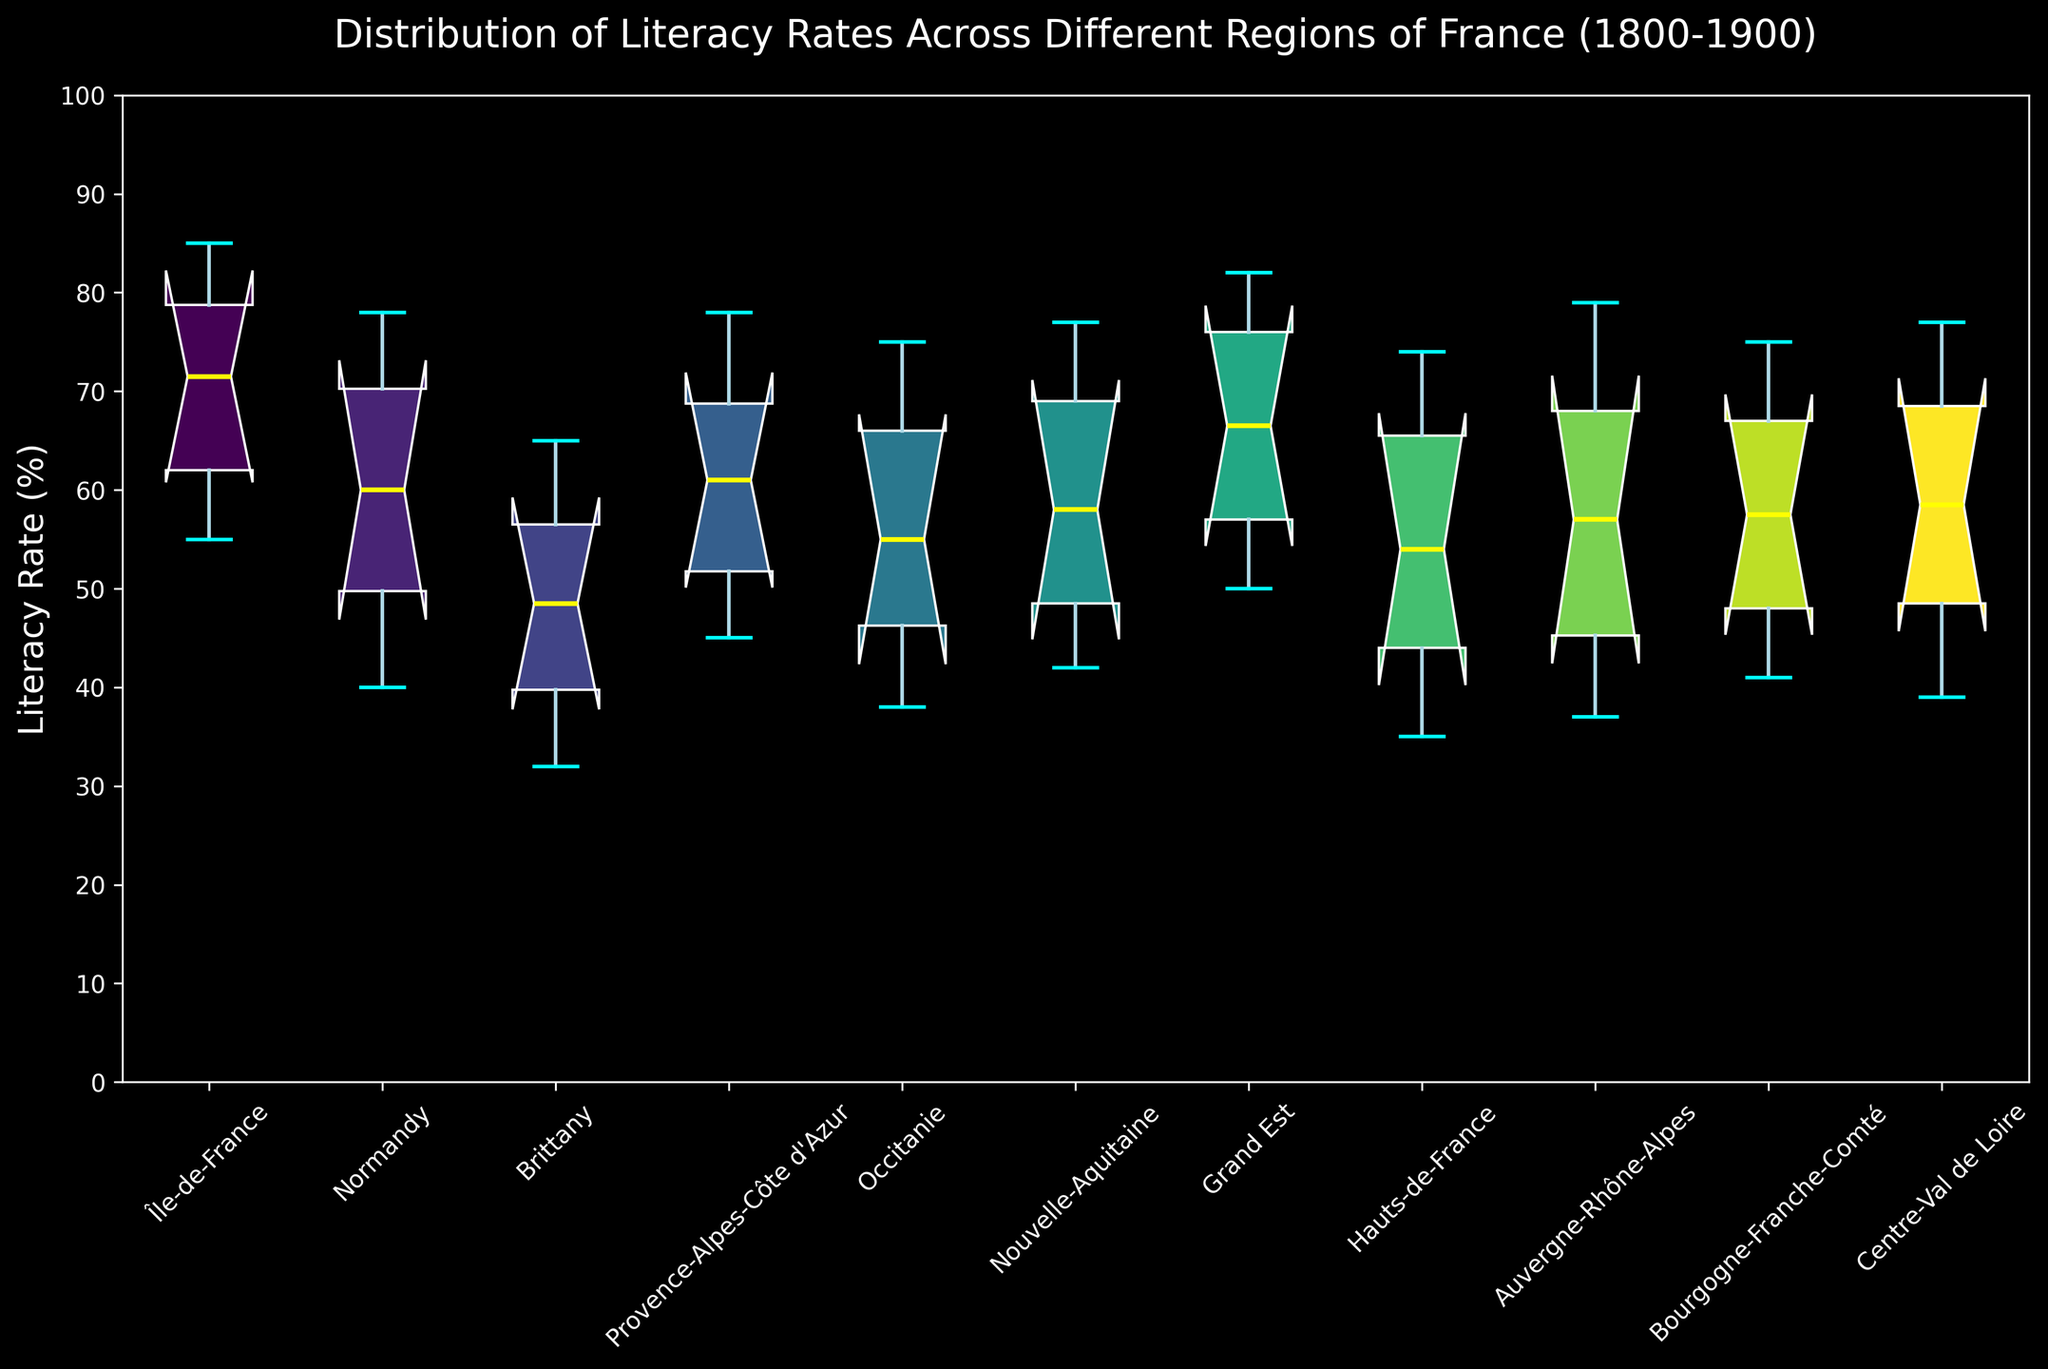What is the median literacy rate for Île-de-France? To find the median literacy rate for Île-de-France on the box plot, look for the line inside the box for Île-de-France. The line represents the median, which in this case is approximately 75%.
Answer: 75% Which region has the highest median literacy rate? By comparing the lines inside each box plot, we can see that Île-de-France has the highest median literacy rate at around 75%.
Answer: Île-de-France What is the range of literacy rates for Brittany over the 19th century? The range is the difference between the maximum and minimum values for Brittany. Look at the top and bottom of the whiskers for Brittany; the values are approximately 65% (max) and 32% (min). So, the range is 65 - 32 = 33%.
Answer: 33% How does the literacy rate distribution in Grand Est compare to Occitanie? To compare the distributions, observe the position and spread of the boxes and whiskers. The median of Grand Est is higher, and the interquartile range (box length) appears smaller compared to Occitanie, indicating less variability in literacy rates.
Answer: Grand Est has a higher median and less variability Which region has the largest interquartile range (IQR)? The IQR is represented by the length of the box. By visually comparing the lengths of the boxes, Centre-Val de Loire has the largest IQR, indicating the most variation within that region.
Answer: Centre-Val de Loire What is the 75th percentile of literacy rates in Normandy? The 75th percentile is the top of the box for Normandy. By observing the graph, the top of the box is around 72%.
Answer: 72% Which region has the smallest range of literacy rates? The range is the distance between the top and bottom of the whiskers. Île-de-France shows the smallest range with closely packed whiskers.
Answer: Île-de-France Are there any outliers in the literacy rates of the regions? Outliers would be indicated by points outside the whiskers (represented by red dots). In this box plot, there are no red dots present, and therefore, there are no outliers.
Answer: No 